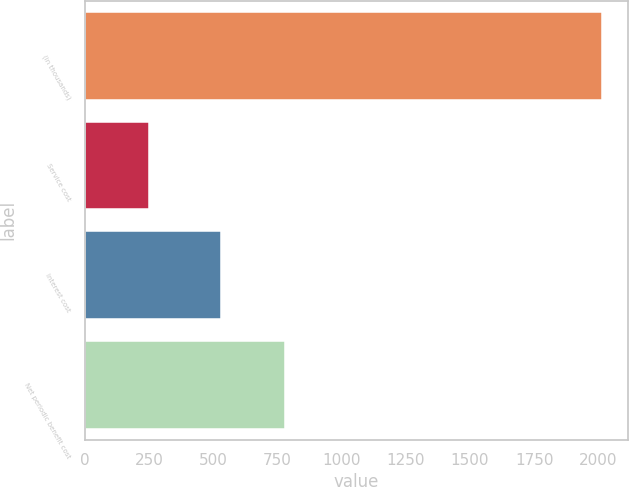Convert chart to OTSL. <chart><loc_0><loc_0><loc_500><loc_500><bar_chart><fcel>(in thousands)<fcel>Service cost<fcel>Interest cost<fcel>Net periodic benefit cost<nl><fcel>2014<fcel>249<fcel>530<fcel>780<nl></chart> 